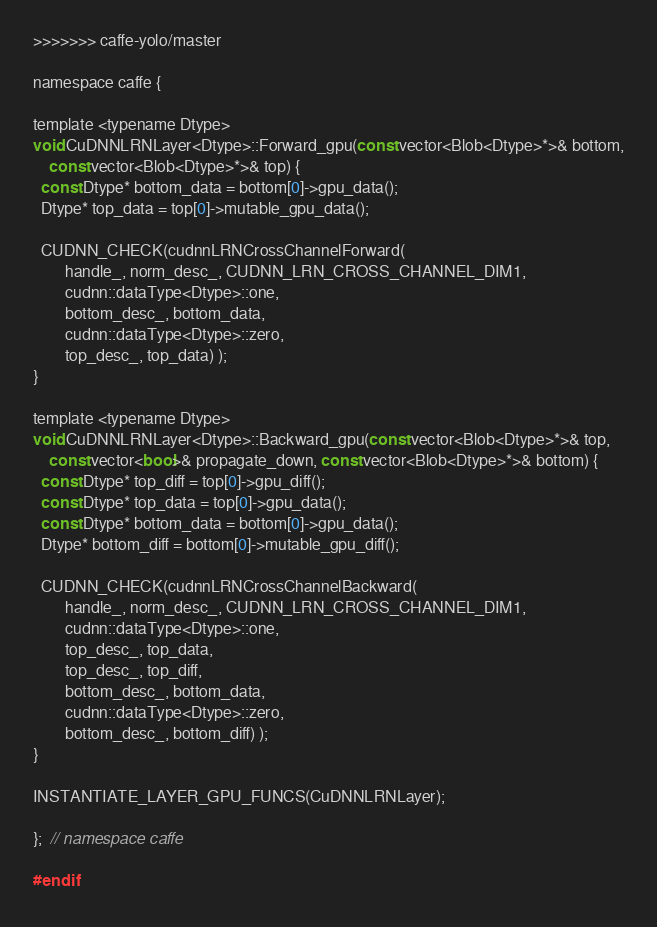<code> <loc_0><loc_0><loc_500><loc_500><_Cuda_>>>>>>>> caffe-yolo/master

namespace caffe {

template <typename Dtype>
void CuDNNLRNLayer<Dtype>::Forward_gpu(const vector<Blob<Dtype>*>& bottom,
    const vector<Blob<Dtype>*>& top) {
  const Dtype* bottom_data = bottom[0]->gpu_data();
  Dtype* top_data = top[0]->mutable_gpu_data();

  CUDNN_CHECK(cudnnLRNCrossChannelForward(
        handle_, norm_desc_, CUDNN_LRN_CROSS_CHANNEL_DIM1,
        cudnn::dataType<Dtype>::one,
        bottom_desc_, bottom_data,
        cudnn::dataType<Dtype>::zero,
        top_desc_, top_data) );
}

template <typename Dtype>
void CuDNNLRNLayer<Dtype>::Backward_gpu(const vector<Blob<Dtype>*>& top,
    const vector<bool>& propagate_down, const vector<Blob<Dtype>*>& bottom) {
  const Dtype* top_diff = top[0]->gpu_diff();
  const Dtype* top_data = top[0]->gpu_data();
  const Dtype* bottom_data = bottom[0]->gpu_data();
  Dtype* bottom_diff = bottom[0]->mutable_gpu_diff();

  CUDNN_CHECK(cudnnLRNCrossChannelBackward(
        handle_, norm_desc_, CUDNN_LRN_CROSS_CHANNEL_DIM1,
        cudnn::dataType<Dtype>::one,
        top_desc_, top_data,
        top_desc_, top_diff,
        bottom_desc_, bottom_data,
        cudnn::dataType<Dtype>::zero,
        bottom_desc_, bottom_diff) );
}

INSTANTIATE_LAYER_GPU_FUNCS(CuDNNLRNLayer);

};  // namespace caffe

#endif
</code> 